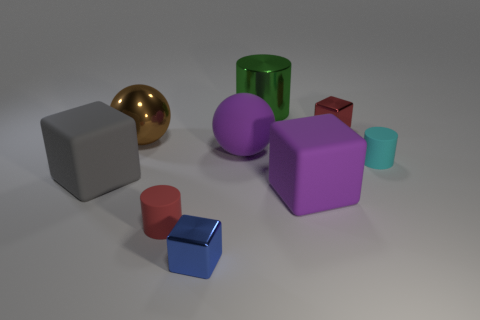Subtract all red cylinders. How many cylinders are left? 2 Subtract 1 cylinders. How many cylinders are left? 2 Add 1 large red metal spheres. How many objects exist? 10 Subtract all gray cubes. How many cubes are left? 3 Subtract all blue blocks. Subtract all blue spheres. How many blocks are left? 3 Subtract all cubes. How many objects are left? 5 Subtract all big brown metal balls. Subtract all big brown things. How many objects are left? 7 Add 2 cyan rubber things. How many cyan rubber things are left? 3 Add 7 red objects. How many red objects exist? 9 Subtract 0 yellow blocks. How many objects are left? 9 